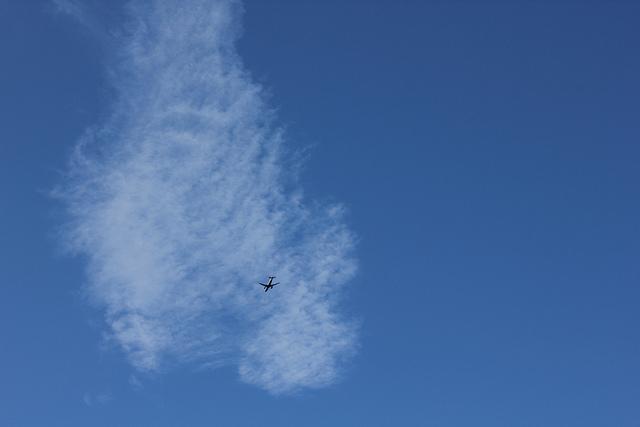What is in the sky?
Concise answer only. Plane. Is the plane in the clouds?
Keep it brief. Yes. Is it going to storm?
Short answer required. No. How many jets are flying?
Quick response, please. 1. Is it a tiny airplane or just far away?
Concise answer only. Far away. How many airplanes are flying in the sky?
Be succinct. 1. Is the sky cloudy or clear?
Write a very short answer. Cloudy. Is it smoky out?
Concise answer only. No. Is this an overcast day?
Write a very short answer. No. Is it cloudy?
Write a very short answer. Yes. How many shades of blue are in this picture?
Keep it brief. 1. A kite is in the sky?
Concise answer only. No. What time of day is it?
Give a very brief answer. Afternoon. Is the plane going to crash?
Keep it brief. No. How big is the plane?
Quick response, please. Small. 